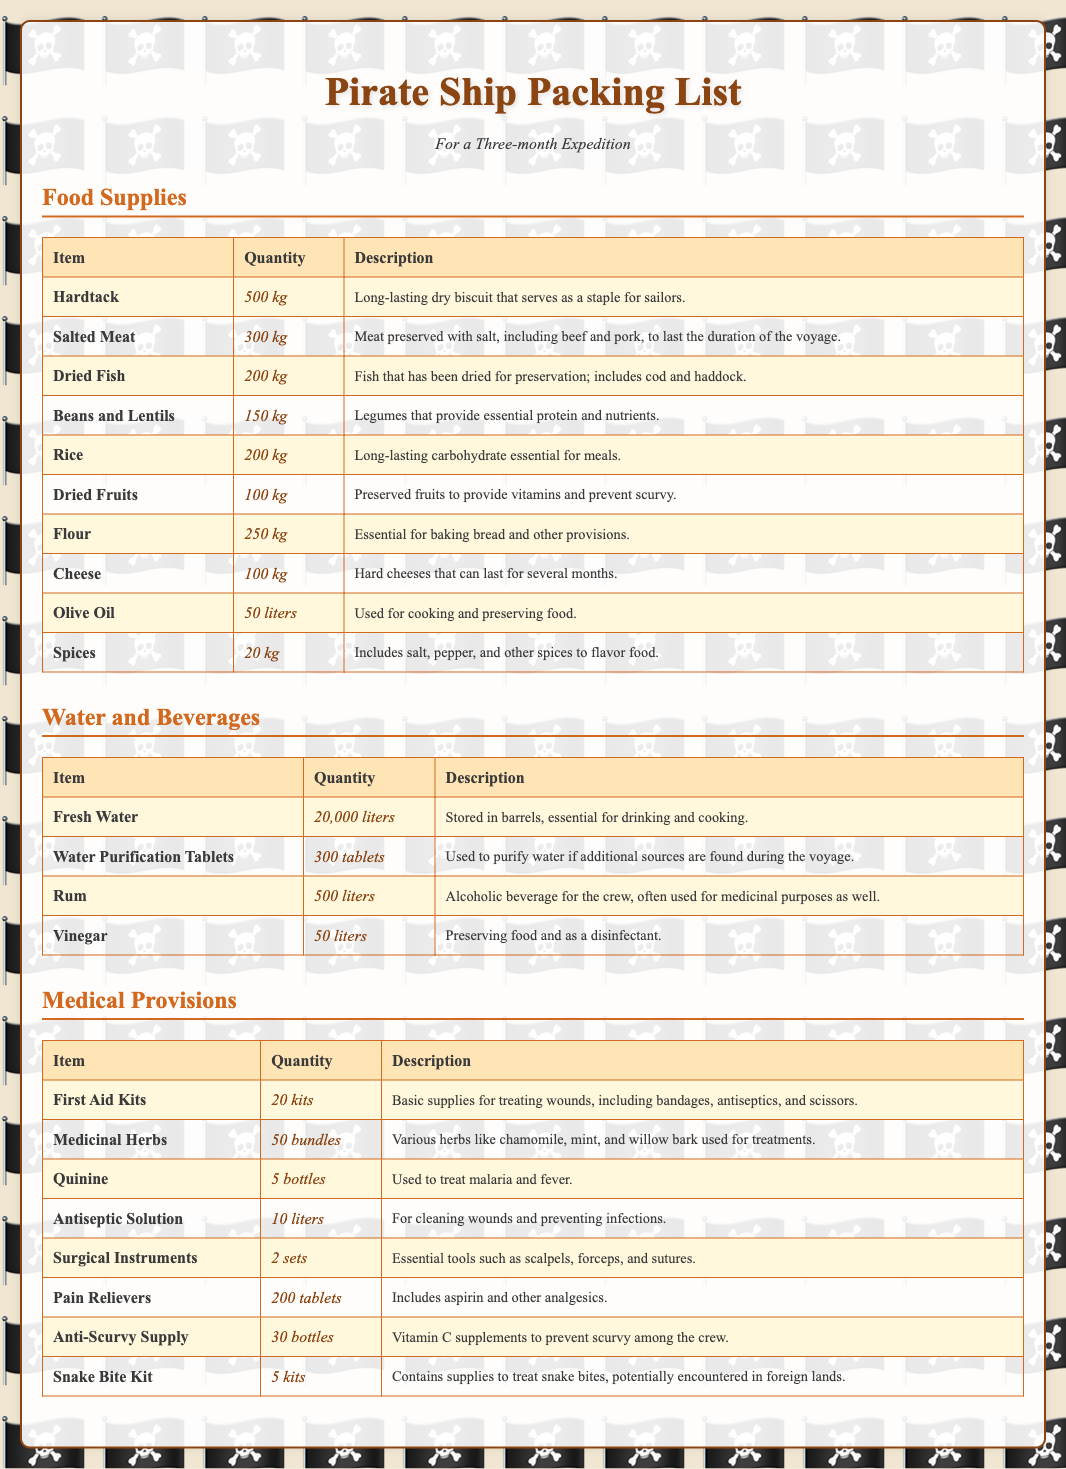What is the total quantity of Hardtack? The quantity of Hardtack listed in the document is 500 kg.
Answer: 500 kg How many liters of Fresh Water are included? The document states that there are 20,000 liters of Fresh Water included.
Answer: 20,000 liters Which food supply is used to prevent scurvy? The item that serves to prevent scurvy is Dried Fruits, which provide vitamins.
Answer: Dried Fruits How many First Aid Kits are available? The document indicates that there are 20 First Aid Kits included in the supplies.
Answer: 20 kits What is the quantity of Anti-Scurvy Supply? The Anti-Scurvy Supply is listed with a quantity of 30 bottles in the document.
Answer: 30 bottles What essential protein source is listed under Food Supplies? The food supply that provides essential protein listed is Beans and Lentils, which is a legume.
Answer: Beans and Lentils How many bottles of Quinine are supplied? The document specifies that there are 5 bottles of Quinine included.
Answer: 5 bottles What is the quantity of Rum provided for the expedition? The recorded quantity of Rum included in the supplies is 500 liters.
Answer: 500 liters Which medical provision contains supplies for treating snake bites? The supply that contains treatment for snake bites is the Snake Bite Kit.
Answer: Snake Bite Kit 